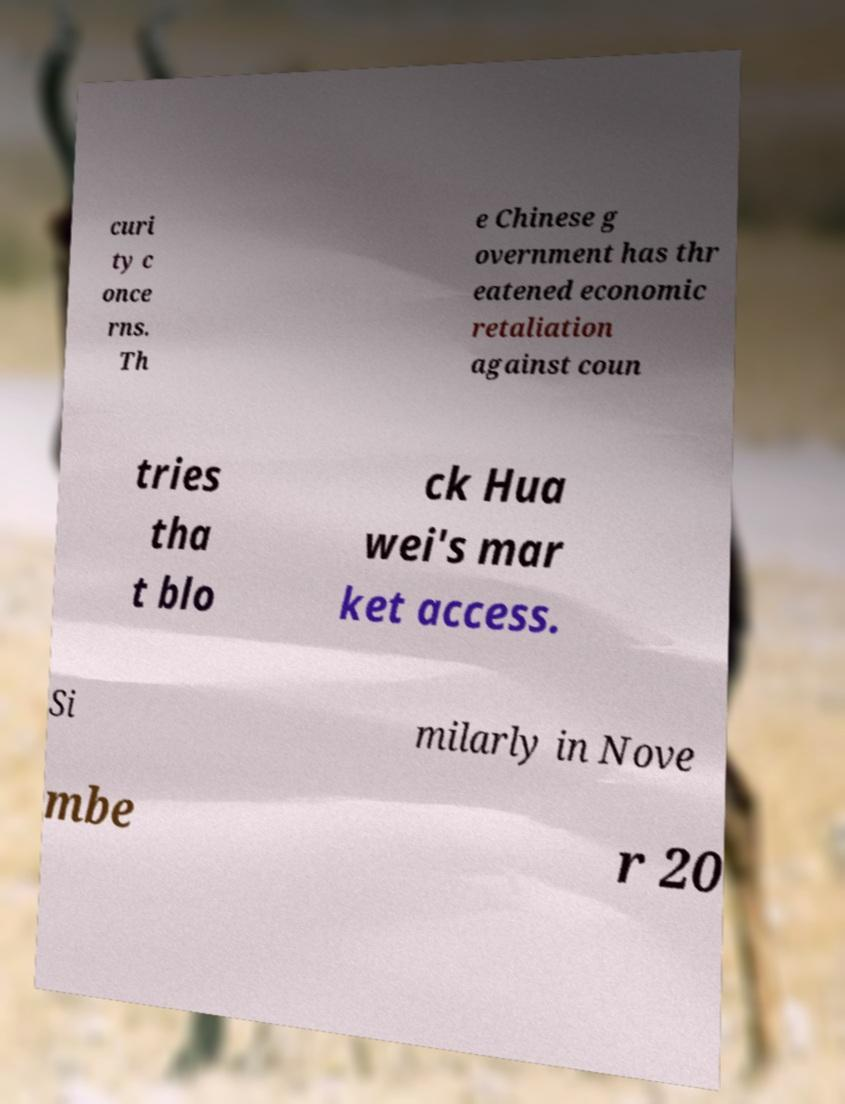Please identify and transcribe the text found in this image. curi ty c once rns. Th e Chinese g overnment has thr eatened economic retaliation against coun tries tha t blo ck Hua wei's mar ket access. Si milarly in Nove mbe r 20 